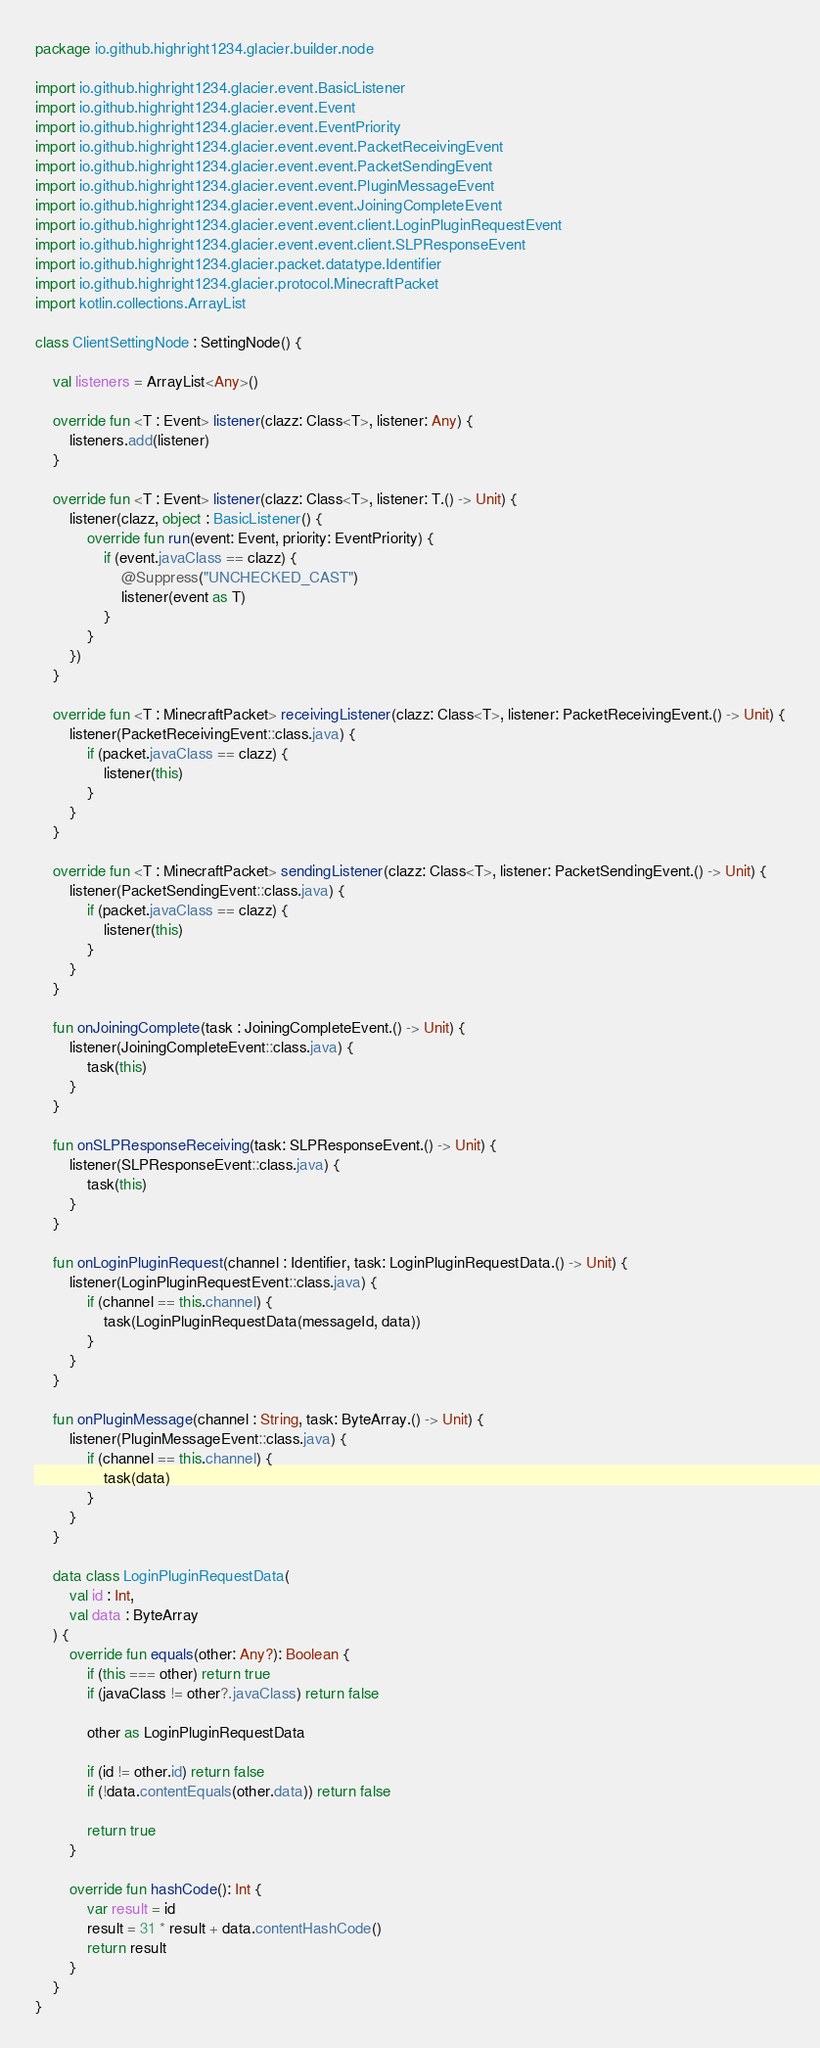Convert code to text. <code><loc_0><loc_0><loc_500><loc_500><_Kotlin_>package io.github.highright1234.glacier.builder.node

import io.github.highright1234.glacier.event.BasicListener
import io.github.highright1234.glacier.event.Event
import io.github.highright1234.glacier.event.EventPriority
import io.github.highright1234.glacier.event.event.PacketReceivingEvent
import io.github.highright1234.glacier.event.event.PacketSendingEvent
import io.github.highright1234.glacier.event.event.PluginMessageEvent
import io.github.highright1234.glacier.event.event.JoiningCompleteEvent
import io.github.highright1234.glacier.event.event.client.LoginPluginRequestEvent
import io.github.highright1234.glacier.event.event.client.SLPResponseEvent
import io.github.highright1234.glacier.packet.datatype.Identifier
import io.github.highright1234.glacier.protocol.MinecraftPacket
import kotlin.collections.ArrayList

class ClientSettingNode : SettingNode() {

    val listeners = ArrayList<Any>()

    override fun <T : Event> listener(clazz: Class<T>, listener: Any) {
        listeners.add(listener)
    }

    override fun <T : Event> listener(clazz: Class<T>, listener: T.() -> Unit) {
        listener(clazz, object : BasicListener() {
            override fun run(event: Event, priority: EventPriority) {
                if (event.javaClass == clazz) {
                    @Suppress("UNCHECKED_CAST")
                    listener(event as T)
                }
            }
        })
    }

    override fun <T : MinecraftPacket> receivingListener(clazz: Class<T>, listener: PacketReceivingEvent.() -> Unit) {
        listener(PacketReceivingEvent::class.java) {
            if (packet.javaClass == clazz) {
                listener(this)
            }
        }
    }

    override fun <T : MinecraftPacket> sendingListener(clazz: Class<T>, listener: PacketSendingEvent.() -> Unit) {
        listener(PacketSendingEvent::class.java) {
            if (packet.javaClass == clazz) {
                listener(this)
            }
        }
    }

    fun onJoiningComplete(task : JoiningCompleteEvent.() -> Unit) {
        listener(JoiningCompleteEvent::class.java) {
            task(this)
        }
    }

    fun onSLPResponseReceiving(task: SLPResponseEvent.() -> Unit) {
        listener(SLPResponseEvent::class.java) {
            task(this)
        }
    }

    fun onLoginPluginRequest(channel : Identifier, task: LoginPluginRequestData.() -> Unit) {
        listener(LoginPluginRequestEvent::class.java) {
            if (channel == this.channel) {
                task(LoginPluginRequestData(messageId, data))
            }
        }
    }

    fun onPluginMessage(channel : String, task: ByteArray.() -> Unit) {
        listener(PluginMessageEvent::class.java) {
            if (channel == this.channel) {
                task(data)
            }
        }
    }

    data class LoginPluginRequestData(
        val id : Int,
        val data : ByteArray
    ) {
        override fun equals(other: Any?): Boolean {
            if (this === other) return true
            if (javaClass != other?.javaClass) return false

            other as LoginPluginRequestData

            if (id != other.id) return false
            if (!data.contentEquals(other.data)) return false

            return true
        }

        override fun hashCode(): Int {
            var result = id
            result = 31 * result + data.contentHashCode()
            return result
        }
    }
}</code> 